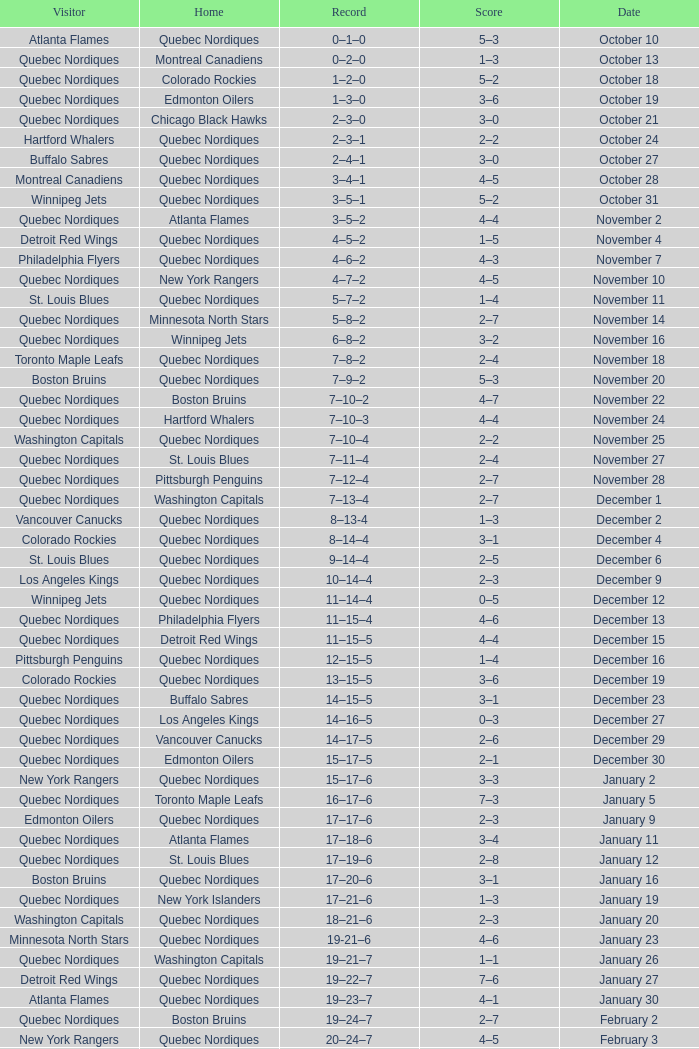Which Home has a Date of april 1? Quebec Nordiques. 